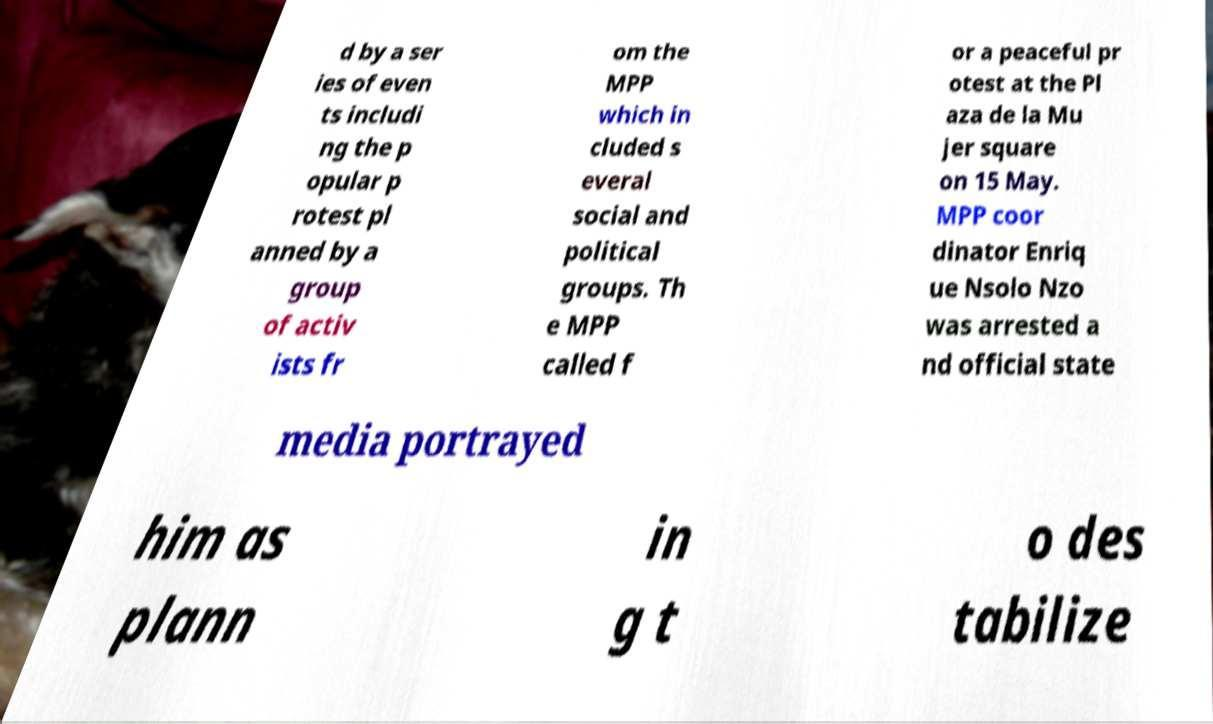Could you assist in decoding the text presented in this image and type it out clearly? d by a ser ies of even ts includi ng the p opular p rotest pl anned by a group of activ ists fr om the MPP which in cluded s everal social and political groups. Th e MPP called f or a peaceful pr otest at the Pl aza de la Mu jer square on 15 May. MPP coor dinator Enriq ue Nsolo Nzo was arrested a nd official state media portrayed him as plann in g t o des tabilize 